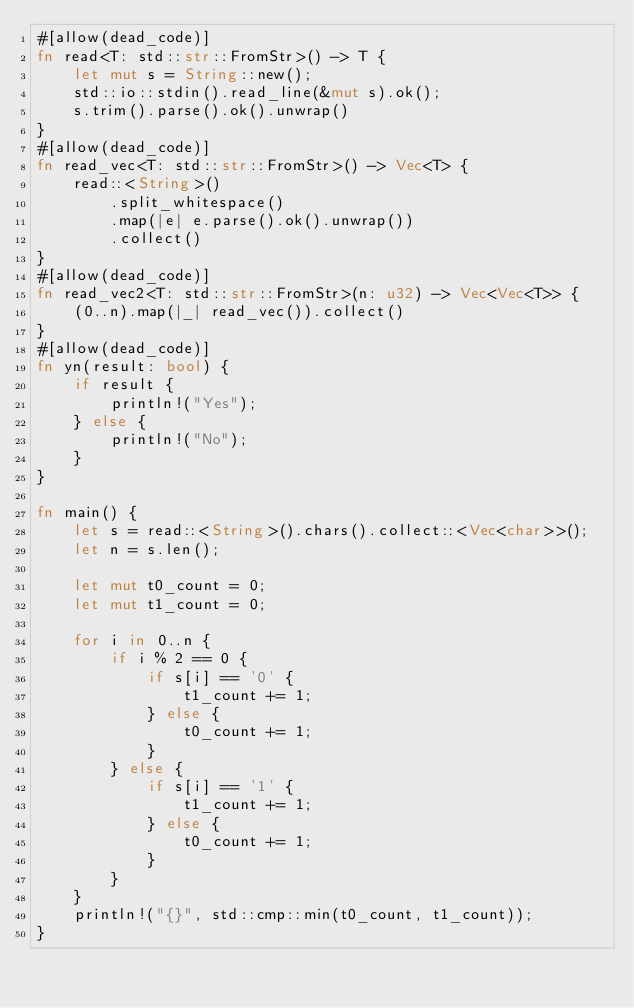<code> <loc_0><loc_0><loc_500><loc_500><_Rust_>#[allow(dead_code)]
fn read<T: std::str::FromStr>() -> T {
    let mut s = String::new();
    std::io::stdin().read_line(&mut s).ok();
    s.trim().parse().ok().unwrap()
}
#[allow(dead_code)]
fn read_vec<T: std::str::FromStr>() -> Vec<T> {
    read::<String>()
        .split_whitespace()
        .map(|e| e.parse().ok().unwrap())
        .collect()
}
#[allow(dead_code)]
fn read_vec2<T: std::str::FromStr>(n: u32) -> Vec<Vec<T>> {
    (0..n).map(|_| read_vec()).collect()
}
#[allow(dead_code)]
fn yn(result: bool) {
    if result {
        println!("Yes");
    } else {
        println!("No");
    }
}

fn main() {
    let s = read::<String>().chars().collect::<Vec<char>>();
    let n = s.len();

    let mut t0_count = 0;
    let mut t1_count = 0;

    for i in 0..n {
        if i % 2 == 0 {
            if s[i] == '0' {
                t1_count += 1;
            } else {
                t0_count += 1;
            }
        } else {
            if s[i] == '1' {
                t1_count += 1;
            } else {
                t0_count += 1;
            }
        }
    }
    println!("{}", std::cmp::min(t0_count, t1_count));
}
</code> 